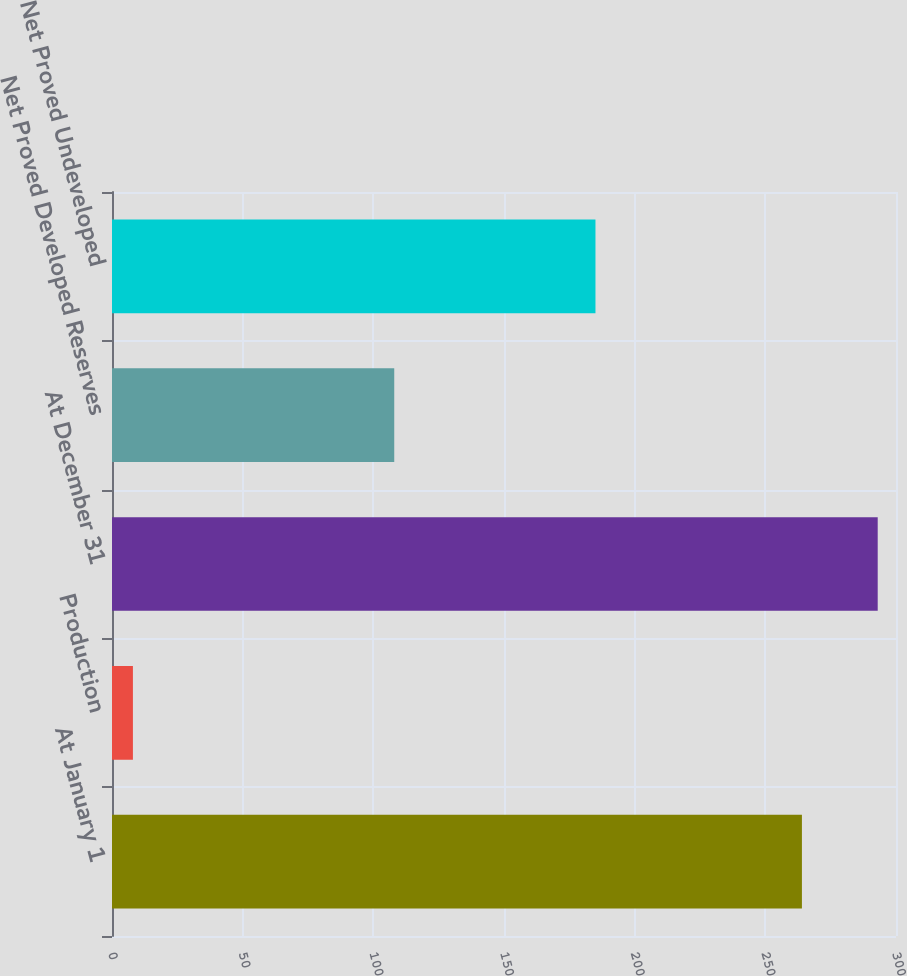Convert chart to OTSL. <chart><loc_0><loc_0><loc_500><loc_500><bar_chart><fcel>At January 1<fcel>Production<fcel>At December 31<fcel>Net Proved Developed Reserves<fcel>Net Proved Undeveloped<nl><fcel>264<fcel>8<fcel>293<fcel>108<fcel>185<nl></chart> 